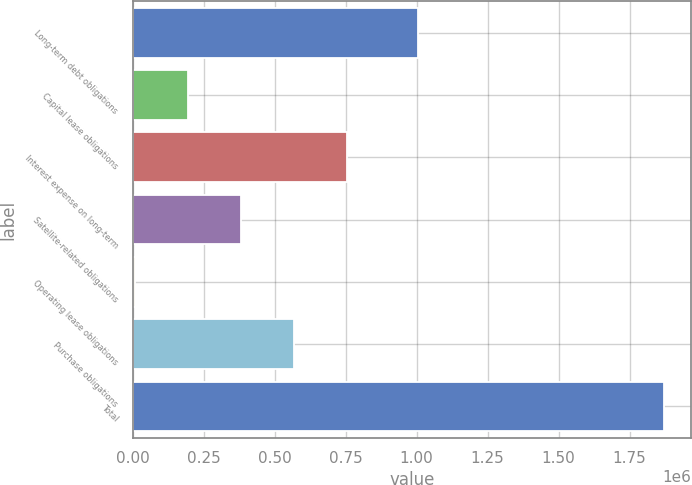<chart> <loc_0><loc_0><loc_500><loc_500><bar_chart><fcel>Long-term debt obligations<fcel>Capital lease obligations<fcel>Interest expense on long-term<fcel>Satellite-related obligations<fcel>Operating lease obligations<fcel>Purchase obligations<fcel>Total<nl><fcel>1.00578e+06<fcel>194776<fcel>754038<fcel>381196<fcel>8355<fcel>567617<fcel>1.87256e+06<nl></chart> 